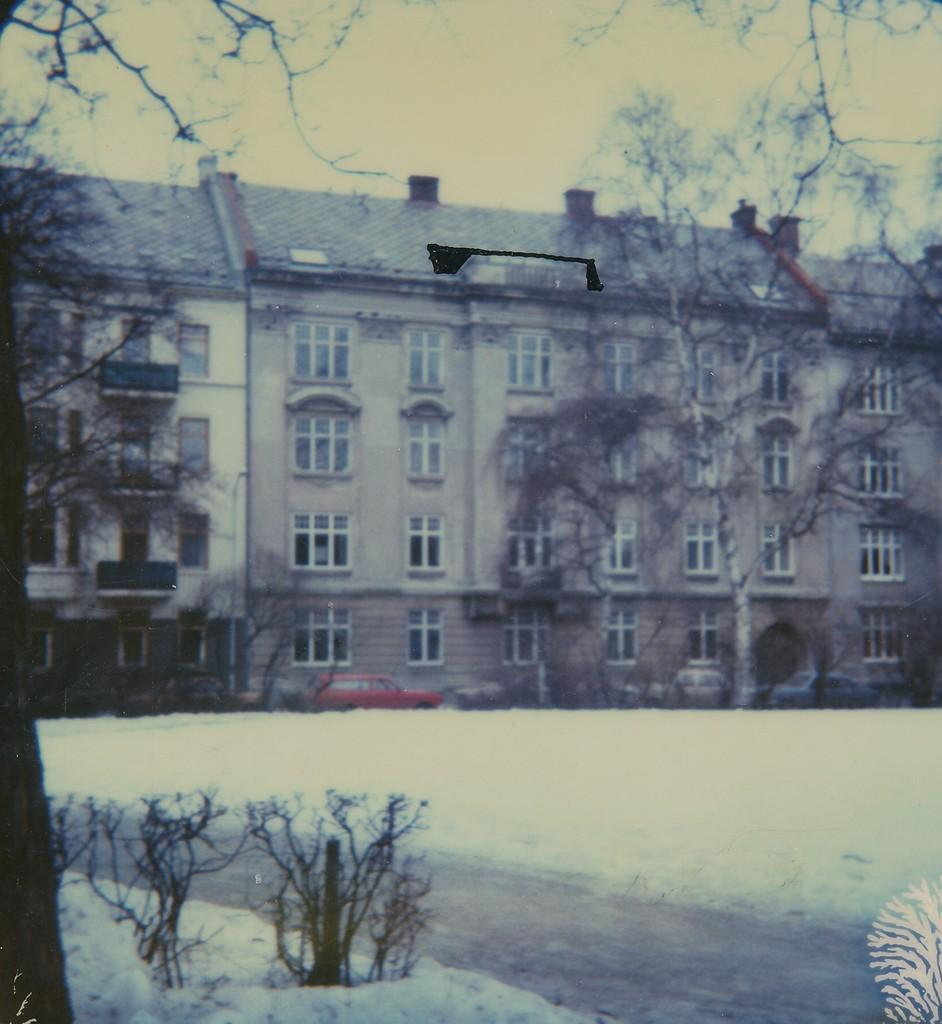What type of surface can be seen in the image? There is a road in the image. What is covering the ground in the image? There is snow on the ground. What type of natural elements are present in the image? There are trees in the image. What man-made structures can be seen in the image? There are vehicles and a building in the image. What feature of the building is mentioned in the facts? The building has windows. What part of the natural environment is visible in the background of the image? The sky is visible in the background of the image. Can you tell me how many lizards are sitting on the building in the image? There are no lizards present in the image; the building has windows and is surrounded by snow, trees, and vehicles. 